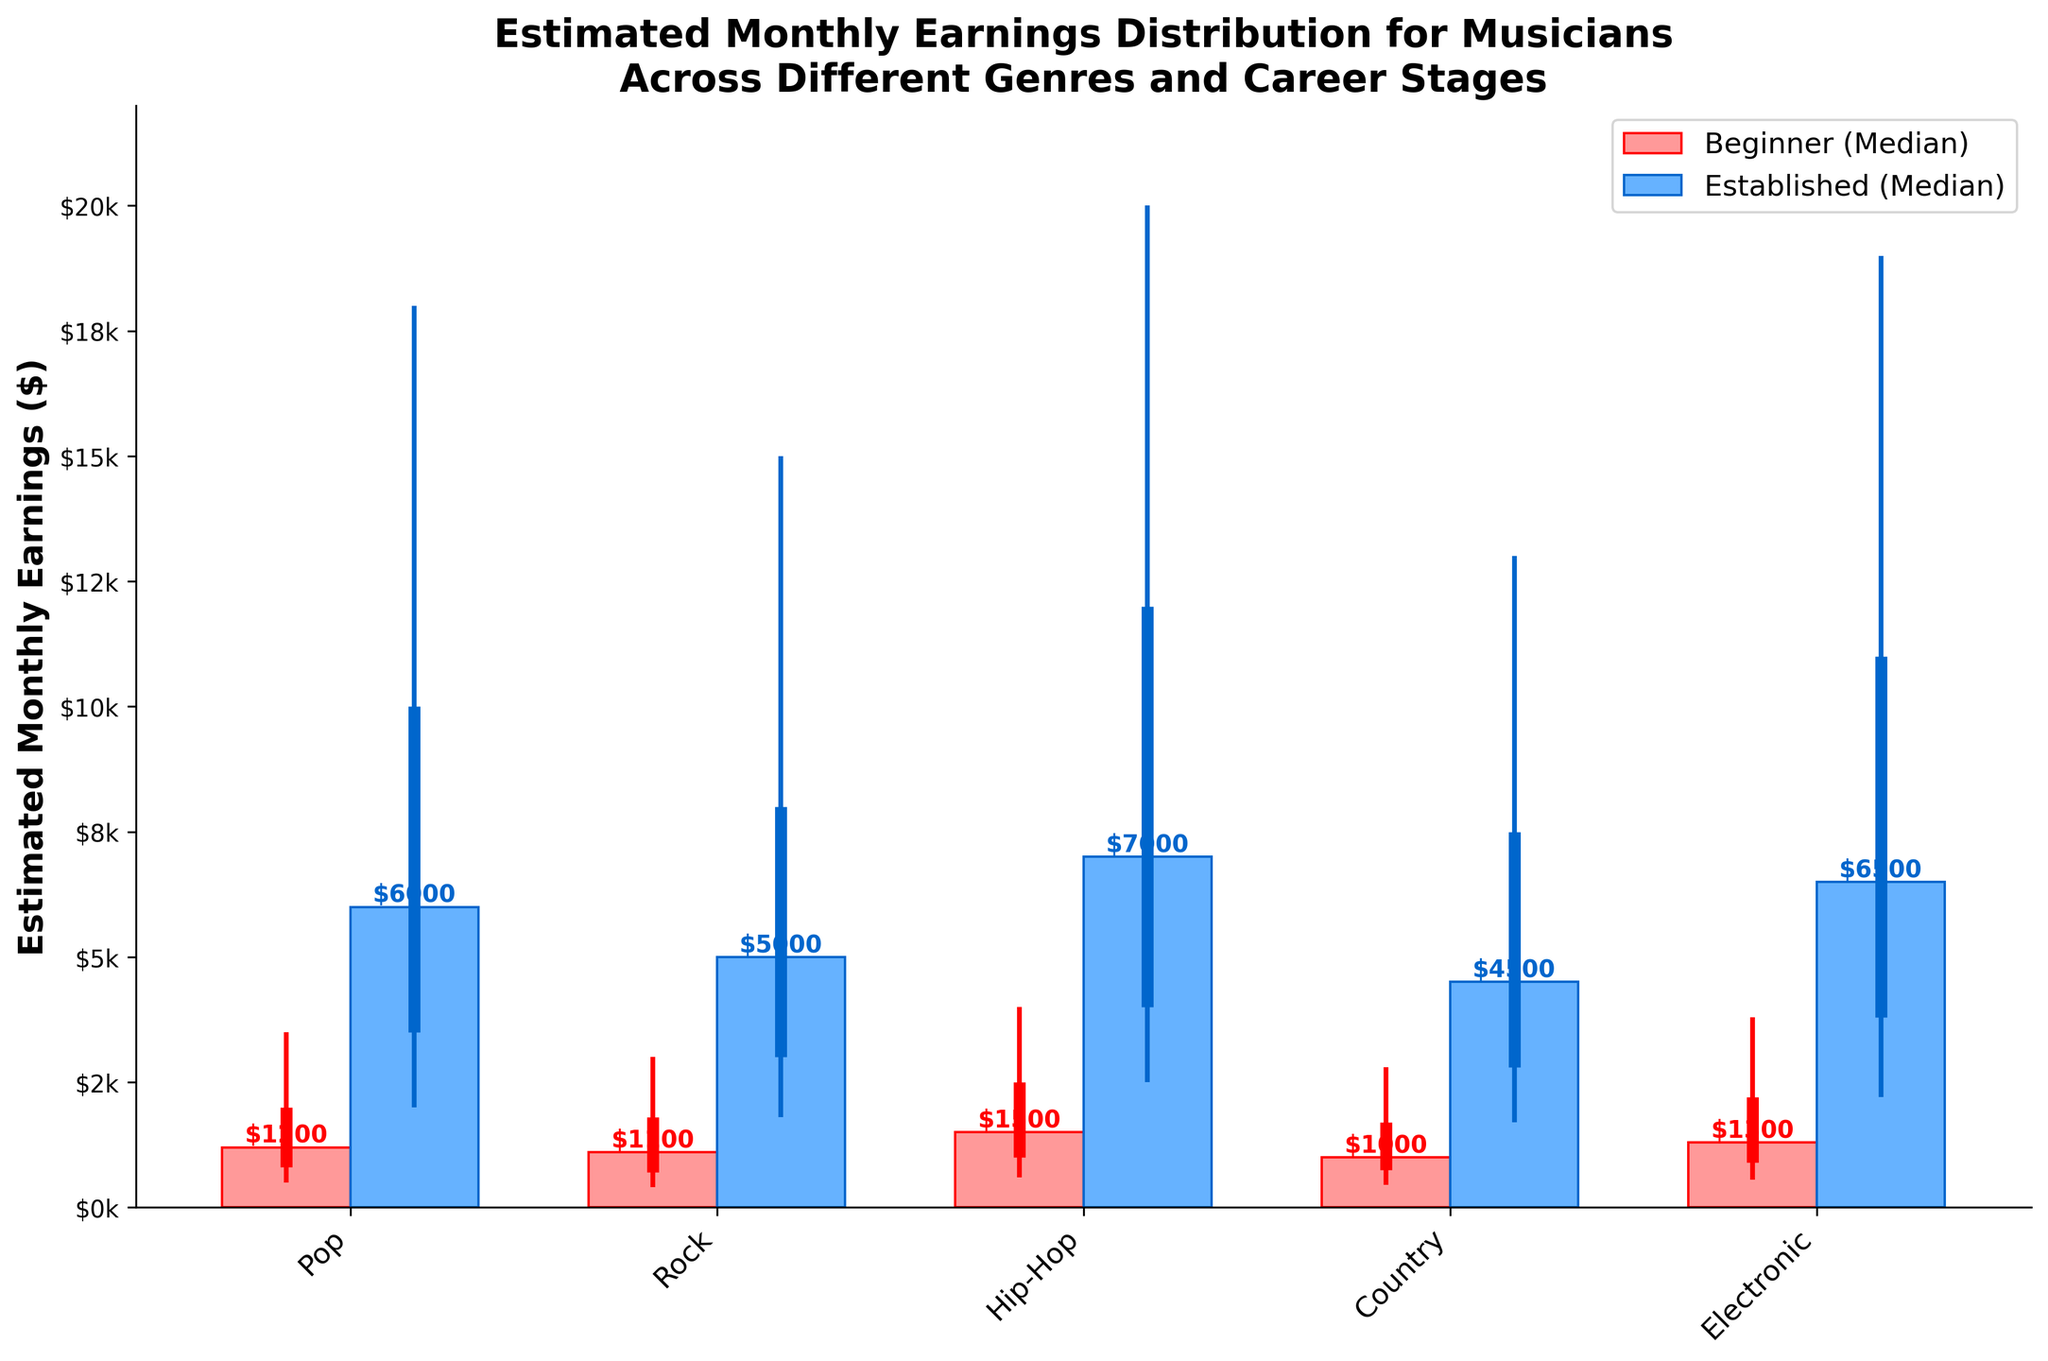what is the title of the figure? The title is usually located at the top of the figure. In this case, it reads "Estimated Monthly Earnings Distribution for Musicians Across Different Genres and Career Stages".
Answer: Estimated Monthly Earnings Distribution for Musicians Across Different Genres and Career Stages what are the genres listed on the x-axis? The genres are listed along the x-axis and are labeled at an angle for readability. The genres shown are Pop, Rock, Hip-Hop, Country, and Electronic.
Answer: Pop, Rock, Hip-Hop, Country, Electronic which genre has the highest median earnings for established musicians? To answer this, look at the bars representing the median in the "Established" category for each genre. Locate the highest bar. Hip-Hop has the highest median earnings for established musicians.
Answer: Hip-Hop how do the median earnings of beginner musicians in Pop compare to those in Country? Compare the height of the median bars for the "Beginner" category in Pop and Country. The median earnings for beginners in Pop ($1200) are higher than those in Country ($1000).
Answer: Higher what is the range between the 10th and 90th percentile for established Country musicians? The range is calculated by subtracting the 10th percentile from the 90th percentile. For established Country musicians, it is $13000 - $1700. Thus, the range is $11300 ($13000 - $1700).
Answer: $11300 which genre shows the largest spread (difference between 10th and 90th percentile) for beginner musicians? Examine the whicker (vertical lines) for the "Beginner" category in each genre. Calculate the spread for each genre. Pop has the largest spread: $3500 - $500 = $3000.
Answer: Pop among beginner musicians, which genre has the lowest 25th percentile earnings? Look at the lower end of the boxes representing the 25th percentile for beginner musicians in each genre. Rock has the lowest 25th percentile earnings at $700.
Answer: Rock which career stage (beginner or established) has a higher median earning for Electronic genre? Compare the median bars for beginner and established Electronic musicians. Established Electronic musicians have a higher median ($6500) compared to beginners ($1300).
Answer: Established which beginner genre has the closest median earnings to the 25th percentile of established Pop musicians? Compare the median earnings of each beginner genre to the 25th percentile earnings of established Pop musicians ($3500). Hip-Hop beginners have a median earning ($1500) closest to it but still lower comparatively.
Answer: Hip-Hop what is the approximate median earnings difference between Beginner Rock musicians and Established Rock musicians? Subtract the median earnings of Beginner Rock musicians from Established Rock musicians. The difference is $5000 - $1100, which equals $3900.
Answer: $3900 